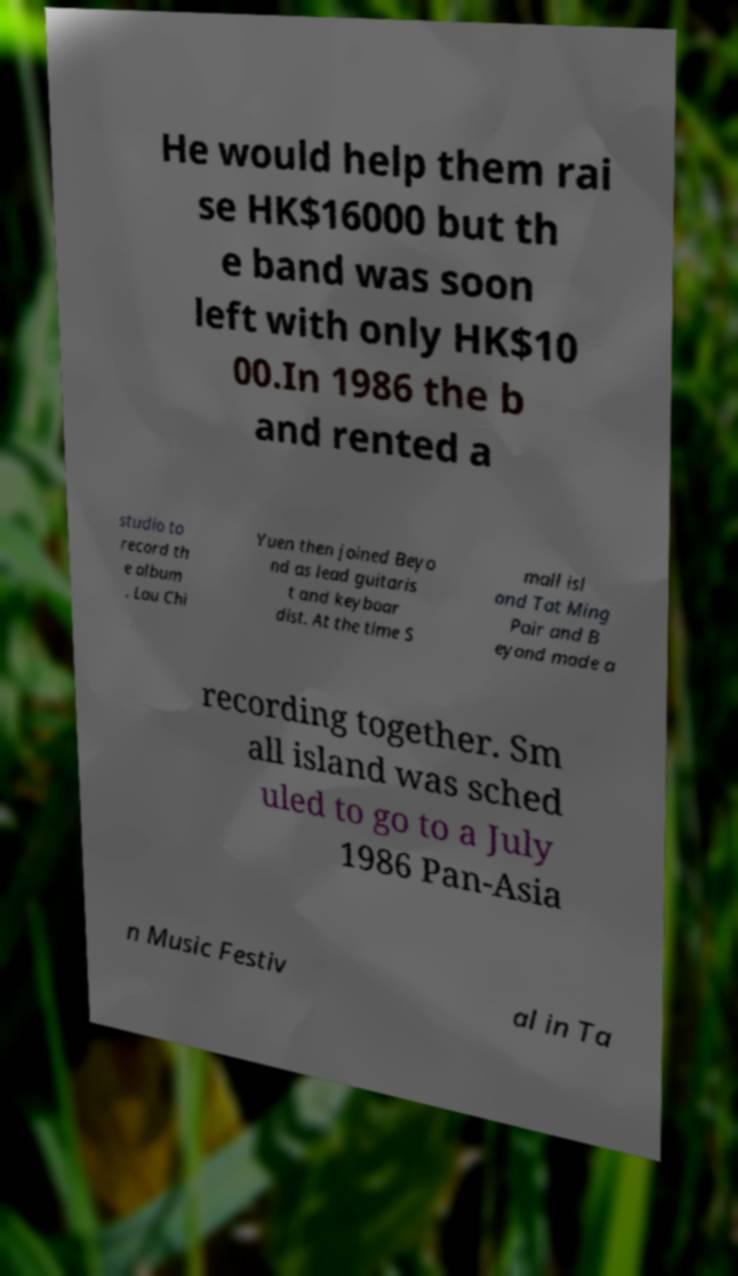Could you assist in decoding the text presented in this image and type it out clearly? He would help them rai se HK$16000 but th e band was soon left with only HK$10 00.In 1986 the b and rented a studio to record th e album . Lau Chi Yuen then joined Beyo nd as lead guitaris t and keyboar dist. At the time S mall isl and Tat Ming Pair and B eyond made a recording together. Sm all island was sched uled to go to a July 1986 Pan-Asia n Music Festiv al in Ta 